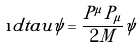Convert formula to latex. <formula><loc_0><loc_0><loc_500><loc_500>\i d t a u \psi = \frac { P ^ { \mu } P _ { \mu } } { 2 M } \psi</formula> 